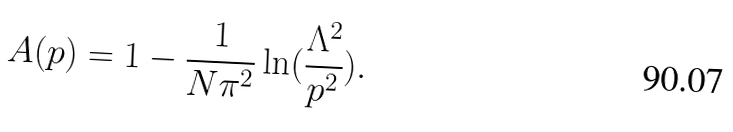Convert formula to latex. <formula><loc_0><loc_0><loc_500><loc_500>A ( p ) = 1 - \frac { 1 } { N \pi ^ { 2 } } \ln ( \frac { \Lambda ^ { 2 } } { p ^ { 2 } } ) .</formula> 